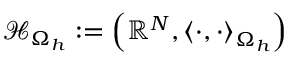<formula> <loc_0><loc_0><loc_500><loc_500>\mathcal { H } _ { \Omega _ { h } } \colon = \left ( \mathbb { R } ^ { N } , \left < \cdot , \cdot \right > _ { \Omega _ { h } } \right )</formula> 